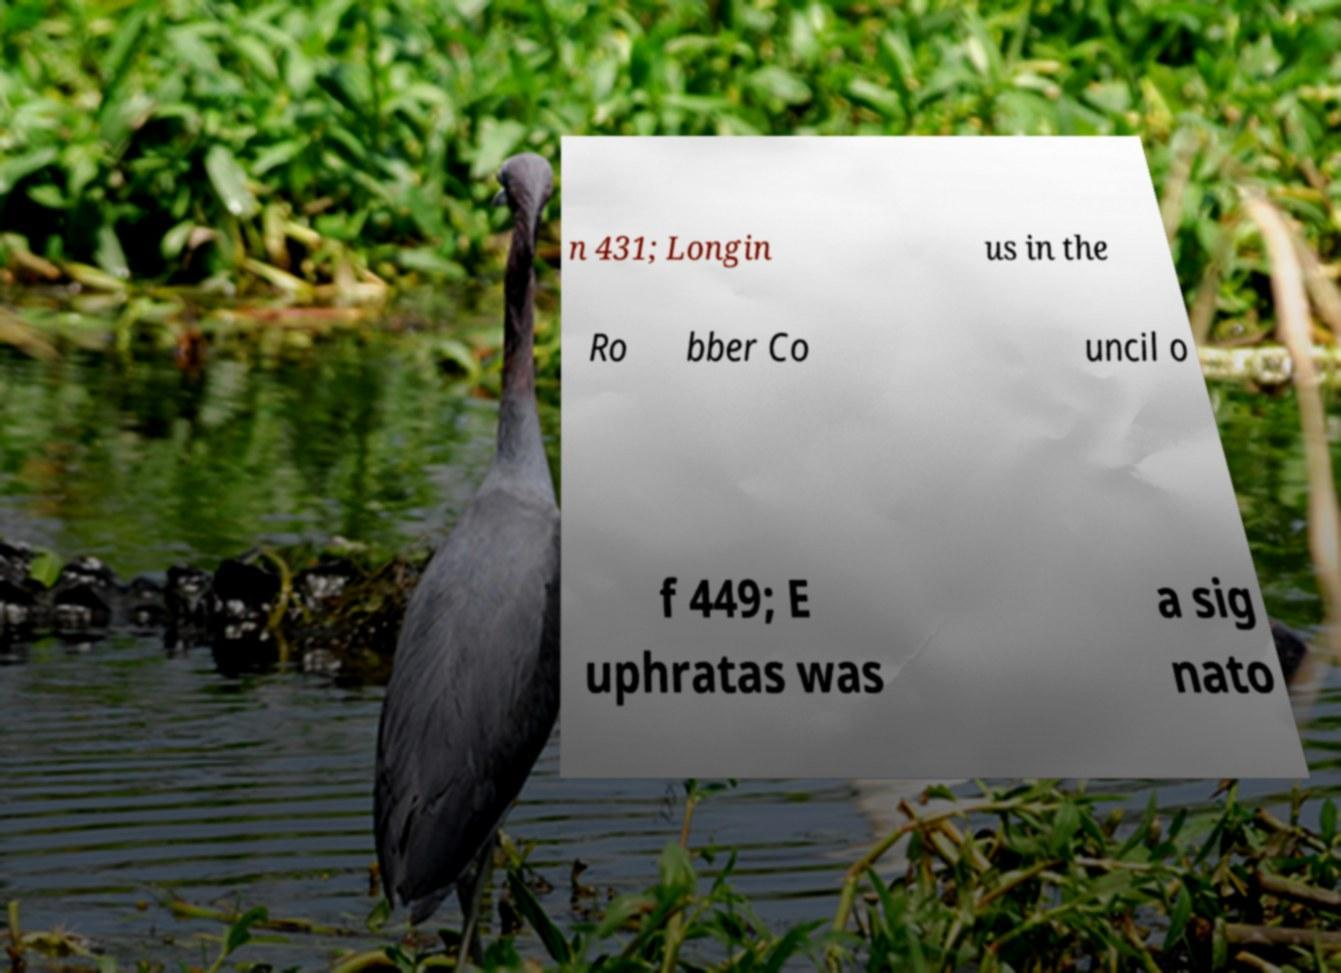For documentation purposes, I need the text within this image transcribed. Could you provide that? n 431; Longin us in the Ro bber Co uncil o f 449; E uphratas was a sig nato 